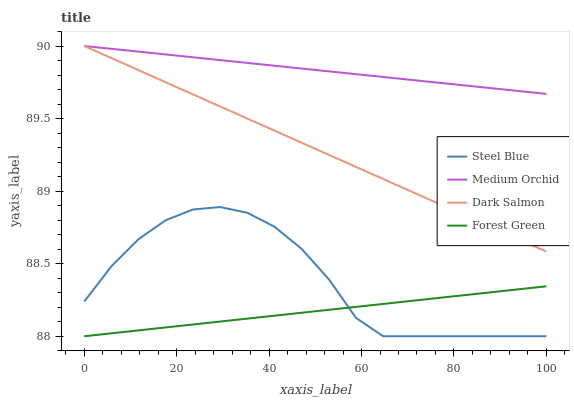Does Forest Green have the minimum area under the curve?
Answer yes or no. Yes. Does Medium Orchid have the maximum area under the curve?
Answer yes or no. Yes. Does Steel Blue have the minimum area under the curve?
Answer yes or no. No. Does Steel Blue have the maximum area under the curve?
Answer yes or no. No. Is Dark Salmon the smoothest?
Answer yes or no. Yes. Is Steel Blue the roughest?
Answer yes or no. Yes. Is Medium Orchid the smoothest?
Answer yes or no. No. Is Medium Orchid the roughest?
Answer yes or no. No. Does Forest Green have the lowest value?
Answer yes or no. Yes. Does Medium Orchid have the lowest value?
Answer yes or no. No. Does Dark Salmon have the highest value?
Answer yes or no. Yes. Does Steel Blue have the highest value?
Answer yes or no. No. Is Steel Blue less than Dark Salmon?
Answer yes or no. Yes. Is Medium Orchid greater than Forest Green?
Answer yes or no. Yes. Does Dark Salmon intersect Medium Orchid?
Answer yes or no. Yes. Is Dark Salmon less than Medium Orchid?
Answer yes or no. No. Is Dark Salmon greater than Medium Orchid?
Answer yes or no. No. Does Steel Blue intersect Dark Salmon?
Answer yes or no. No. 